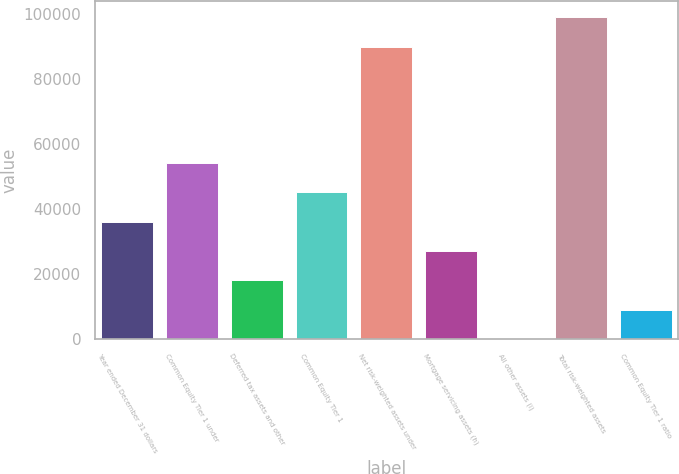<chart> <loc_0><loc_0><loc_500><loc_500><bar_chart><fcel>Year ended December 31 dollars<fcel>Common Equity Tier 1 under<fcel>Deferred tax assets and other<fcel>Common Equity Tier 1<fcel>Net risk-weighted assets under<fcel>Mortgage servicing assets (h)<fcel>All other assets (i)<fcel>Total risk-weighted assets<fcel>Common Equity Tier 1 ratio<nl><fcel>36187.8<fcel>54280.2<fcel>18095.4<fcel>45234<fcel>89980<fcel>27141.6<fcel>3<fcel>99026.2<fcel>9049.2<nl></chart> 